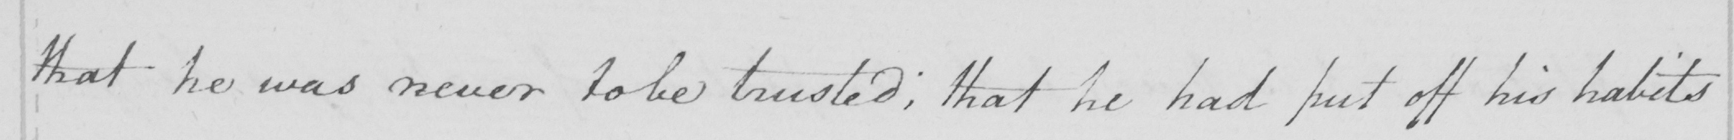Please provide the text content of this handwritten line. that he was never to be trusted ; that he had put off his habits 